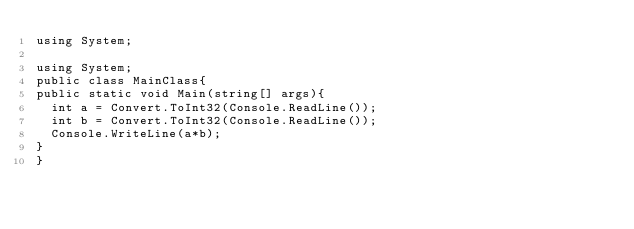<code> <loc_0><loc_0><loc_500><loc_500><_C#_>using System;

using System;
public class MainClass{
public static void Main(string[] args){
	int a = Convert.ToInt32(Console.ReadLine());
  int b = Convert.ToInt32(Console.ReadLine());
	Console.WriteLine(a*b);
}
}
</code> 